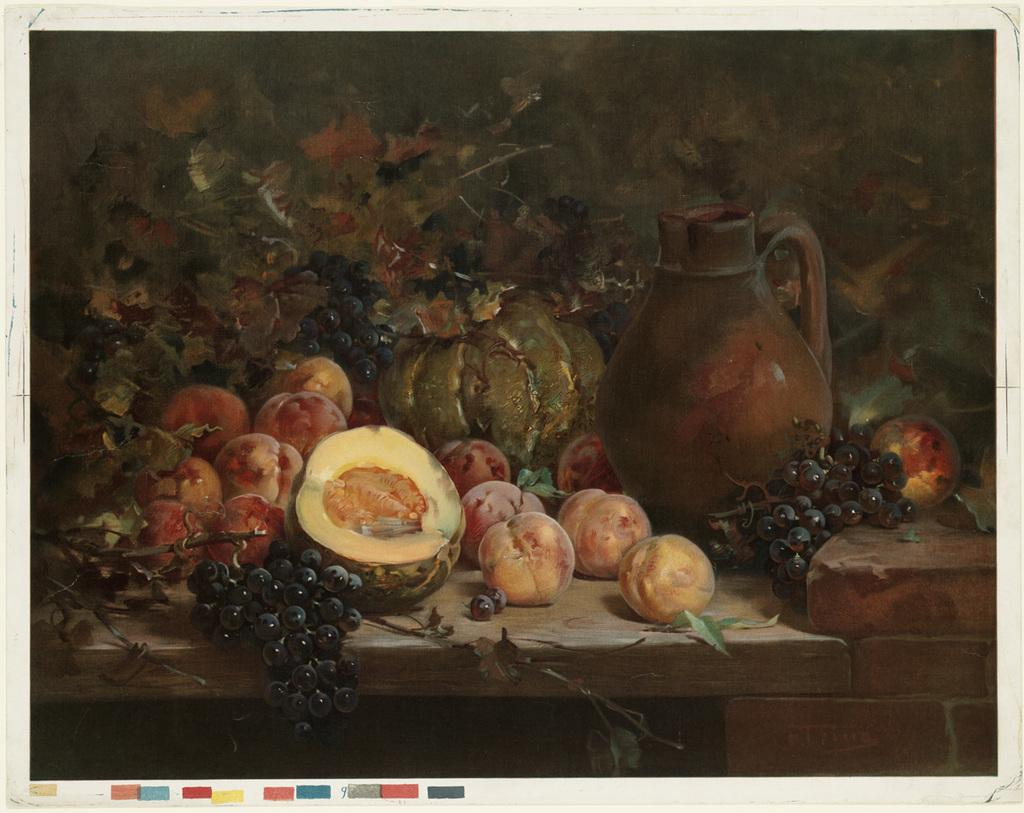What is the main subject of the image? There is a painting in the image. What else can be seen on the table in the image? There is a jug and grapes on the table. Are there any other fruits on the table besides grapes? Yes, there are fruits on the table. How many lizards can be seen crawling on the painting in the image? There are no lizards present in the image; it only features a painting, a jug, grapes, and other fruits on the table. 